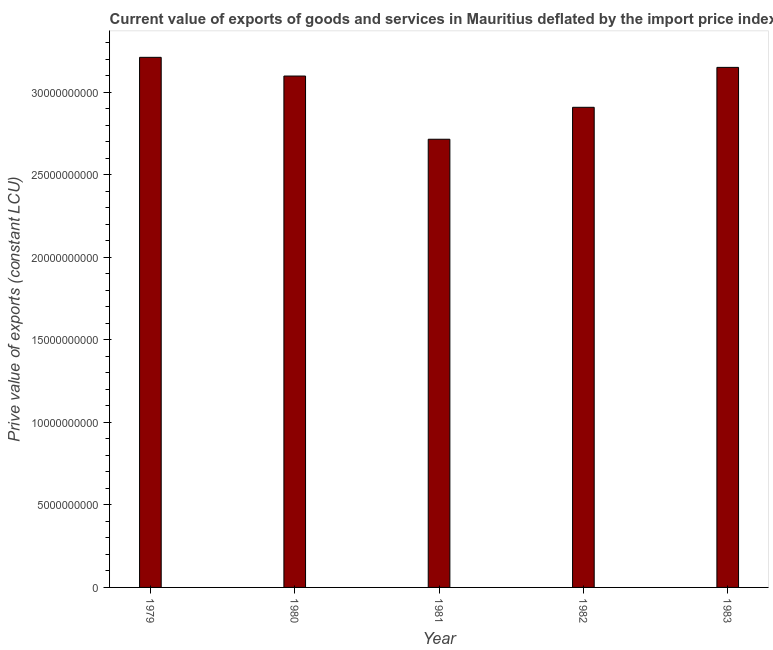Does the graph contain grids?
Keep it short and to the point. No. What is the title of the graph?
Keep it short and to the point. Current value of exports of goods and services in Mauritius deflated by the import price index. What is the label or title of the X-axis?
Your answer should be very brief. Year. What is the label or title of the Y-axis?
Your answer should be very brief. Prive value of exports (constant LCU). What is the price value of exports in 1979?
Provide a succinct answer. 3.21e+1. Across all years, what is the maximum price value of exports?
Ensure brevity in your answer.  3.21e+1. Across all years, what is the minimum price value of exports?
Offer a terse response. 2.71e+1. In which year was the price value of exports maximum?
Offer a terse response. 1979. In which year was the price value of exports minimum?
Offer a terse response. 1981. What is the sum of the price value of exports?
Your answer should be very brief. 1.51e+11. What is the difference between the price value of exports in 1980 and 1981?
Provide a succinct answer. 3.83e+09. What is the average price value of exports per year?
Offer a very short reply. 3.02e+1. What is the median price value of exports?
Your answer should be very brief. 3.10e+1. What is the ratio of the price value of exports in 1979 to that in 1982?
Your answer should be very brief. 1.1. What is the difference between the highest and the second highest price value of exports?
Give a very brief answer. 6.09e+08. What is the difference between the highest and the lowest price value of exports?
Your response must be concise. 4.96e+09. In how many years, is the price value of exports greater than the average price value of exports taken over all years?
Ensure brevity in your answer.  3. How many bars are there?
Your answer should be compact. 5. Are all the bars in the graph horizontal?
Ensure brevity in your answer.  No. What is the Prive value of exports (constant LCU) of 1979?
Your answer should be compact. 3.21e+1. What is the Prive value of exports (constant LCU) in 1980?
Give a very brief answer. 3.10e+1. What is the Prive value of exports (constant LCU) of 1981?
Your response must be concise. 2.71e+1. What is the Prive value of exports (constant LCU) in 1982?
Provide a short and direct response. 2.91e+1. What is the Prive value of exports (constant LCU) in 1983?
Your answer should be compact. 3.15e+1. What is the difference between the Prive value of exports (constant LCU) in 1979 and 1980?
Keep it short and to the point. 1.13e+09. What is the difference between the Prive value of exports (constant LCU) in 1979 and 1981?
Provide a short and direct response. 4.96e+09. What is the difference between the Prive value of exports (constant LCU) in 1979 and 1982?
Give a very brief answer. 3.03e+09. What is the difference between the Prive value of exports (constant LCU) in 1979 and 1983?
Ensure brevity in your answer.  6.09e+08. What is the difference between the Prive value of exports (constant LCU) in 1980 and 1981?
Make the answer very short. 3.83e+09. What is the difference between the Prive value of exports (constant LCU) in 1980 and 1982?
Ensure brevity in your answer.  1.89e+09. What is the difference between the Prive value of exports (constant LCU) in 1980 and 1983?
Your response must be concise. -5.24e+08. What is the difference between the Prive value of exports (constant LCU) in 1981 and 1982?
Give a very brief answer. -1.93e+09. What is the difference between the Prive value of exports (constant LCU) in 1981 and 1983?
Your answer should be compact. -4.35e+09. What is the difference between the Prive value of exports (constant LCU) in 1982 and 1983?
Make the answer very short. -2.42e+09. What is the ratio of the Prive value of exports (constant LCU) in 1979 to that in 1980?
Offer a terse response. 1.04. What is the ratio of the Prive value of exports (constant LCU) in 1979 to that in 1981?
Give a very brief answer. 1.18. What is the ratio of the Prive value of exports (constant LCU) in 1979 to that in 1982?
Offer a terse response. 1.1. What is the ratio of the Prive value of exports (constant LCU) in 1979 to that in 1983?
Provide a short and direct response. 1.02. What is the ratio of the Prive value of exports (constant LCU) in 1980 to that in 1981?
Keep it short and to the point. 1.14. What is the ratio of the Prive value of exports (constant LCU) in 1980 to that in 1982?
Provide a succinct answer. 1.06. What is the ratio of the Prive value of exports (constant LCU) in 1981 to that in 1982?
Make the answer very short. 0.93. What is the ratio of the Prive value of exports (constant LCU) in 1981 to that in 1983?
Provide a short and direct response. 0.86. What is the ratio of the Prive value of exports (constant LCU) in 1982 to that in 1983?
Make the answer very short. 0.92. 